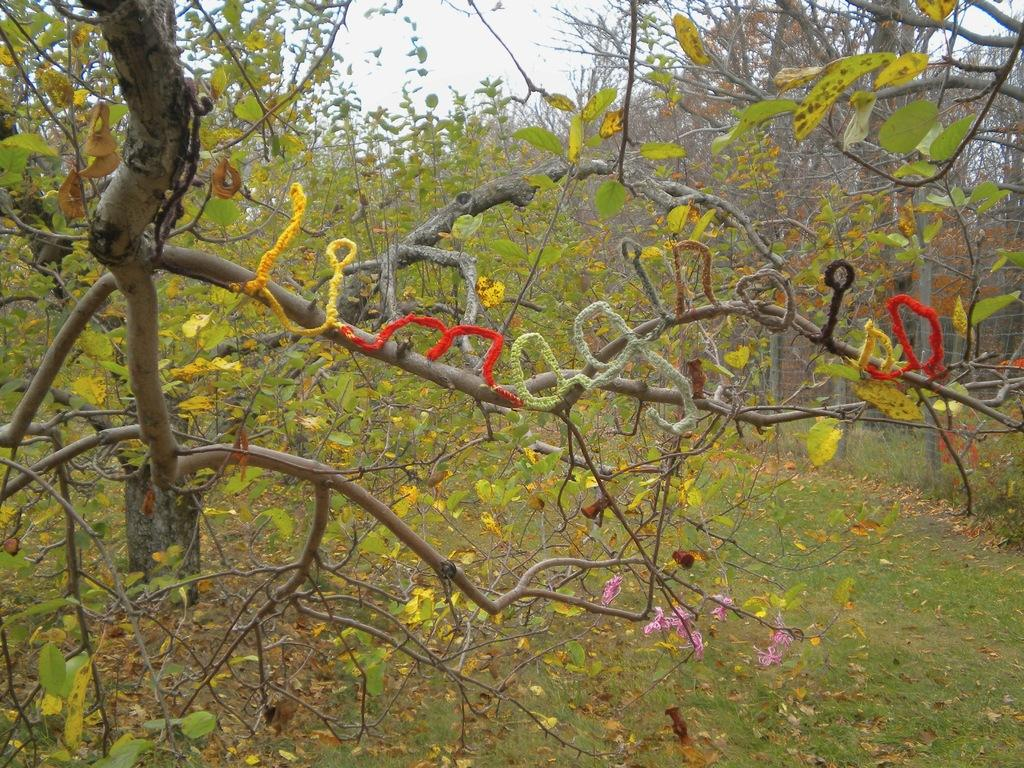What type of vegetation can be seen in the image? There are trees and grass in the image. What else can be found on the ground in the image? Dried leaves are present in the image. What is visible in the background of the image? The sky is visible in the image. What type of cherry is being picked by the fairies in the image? There are no fairies or cherries present in the image. 